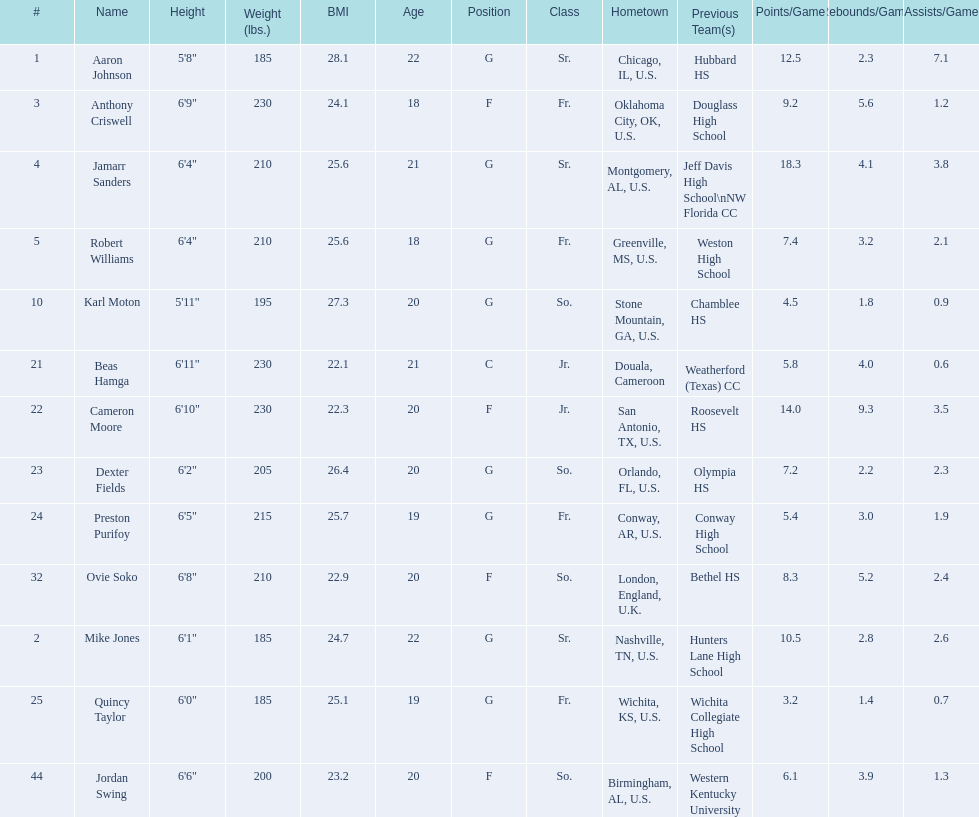Other than soko, who are the players? Aaron Johnson, Anthony Criswell, Jamarr Sanders, Robert Williams, Karl Moton, Beas Hamga, Cameron Moore, Dexter Fields, Preston Purifoy, Mike Jones, Quincy Taylor, Jordan Swing. Of those players, who is a player that is not from the us? Beas Hamga. 